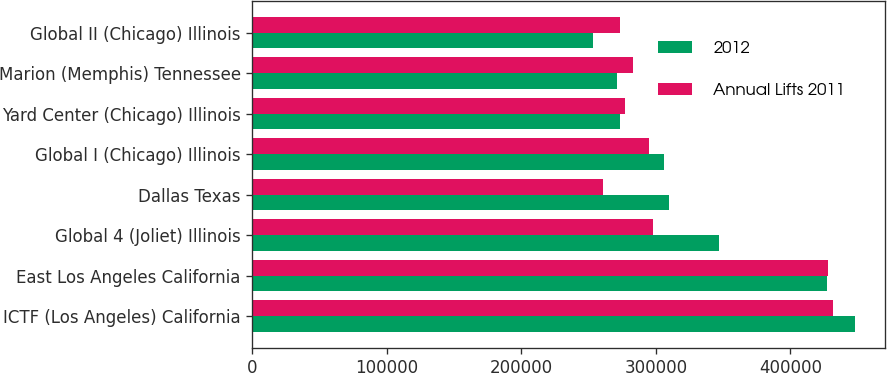Convert chart to OTSL. <chart><loc_0><loc_0><loc_500><loc_500><stacked_bar_chart><ecel><fcel>ICTF (Los Angeles) California<fcel>East Los Angeles California<fcel>Global 4 (Joliet) Illinois<fcel>Dallas Texas<fcel>Global I (Chicago) Illinois<fcel>Yard Center (Chicago) Illinois<fcel>Marion (Memphis) Tennessee<fcel>Global II (Chicago) Illinois<nl><fcel>2012<fcel>448000<fcel>427000<fcel>347000<fcel>310000<fcel>306000<fcel>273000<fcel>271000<fcel>253000<nl><fcel>Annual Lifts 2011<fcel>432000<fcel>428000<fcel>298000<fcel>261000<fcel>295000<fcel>277000<fcel>283000<fcel>273000<nl></chart> 